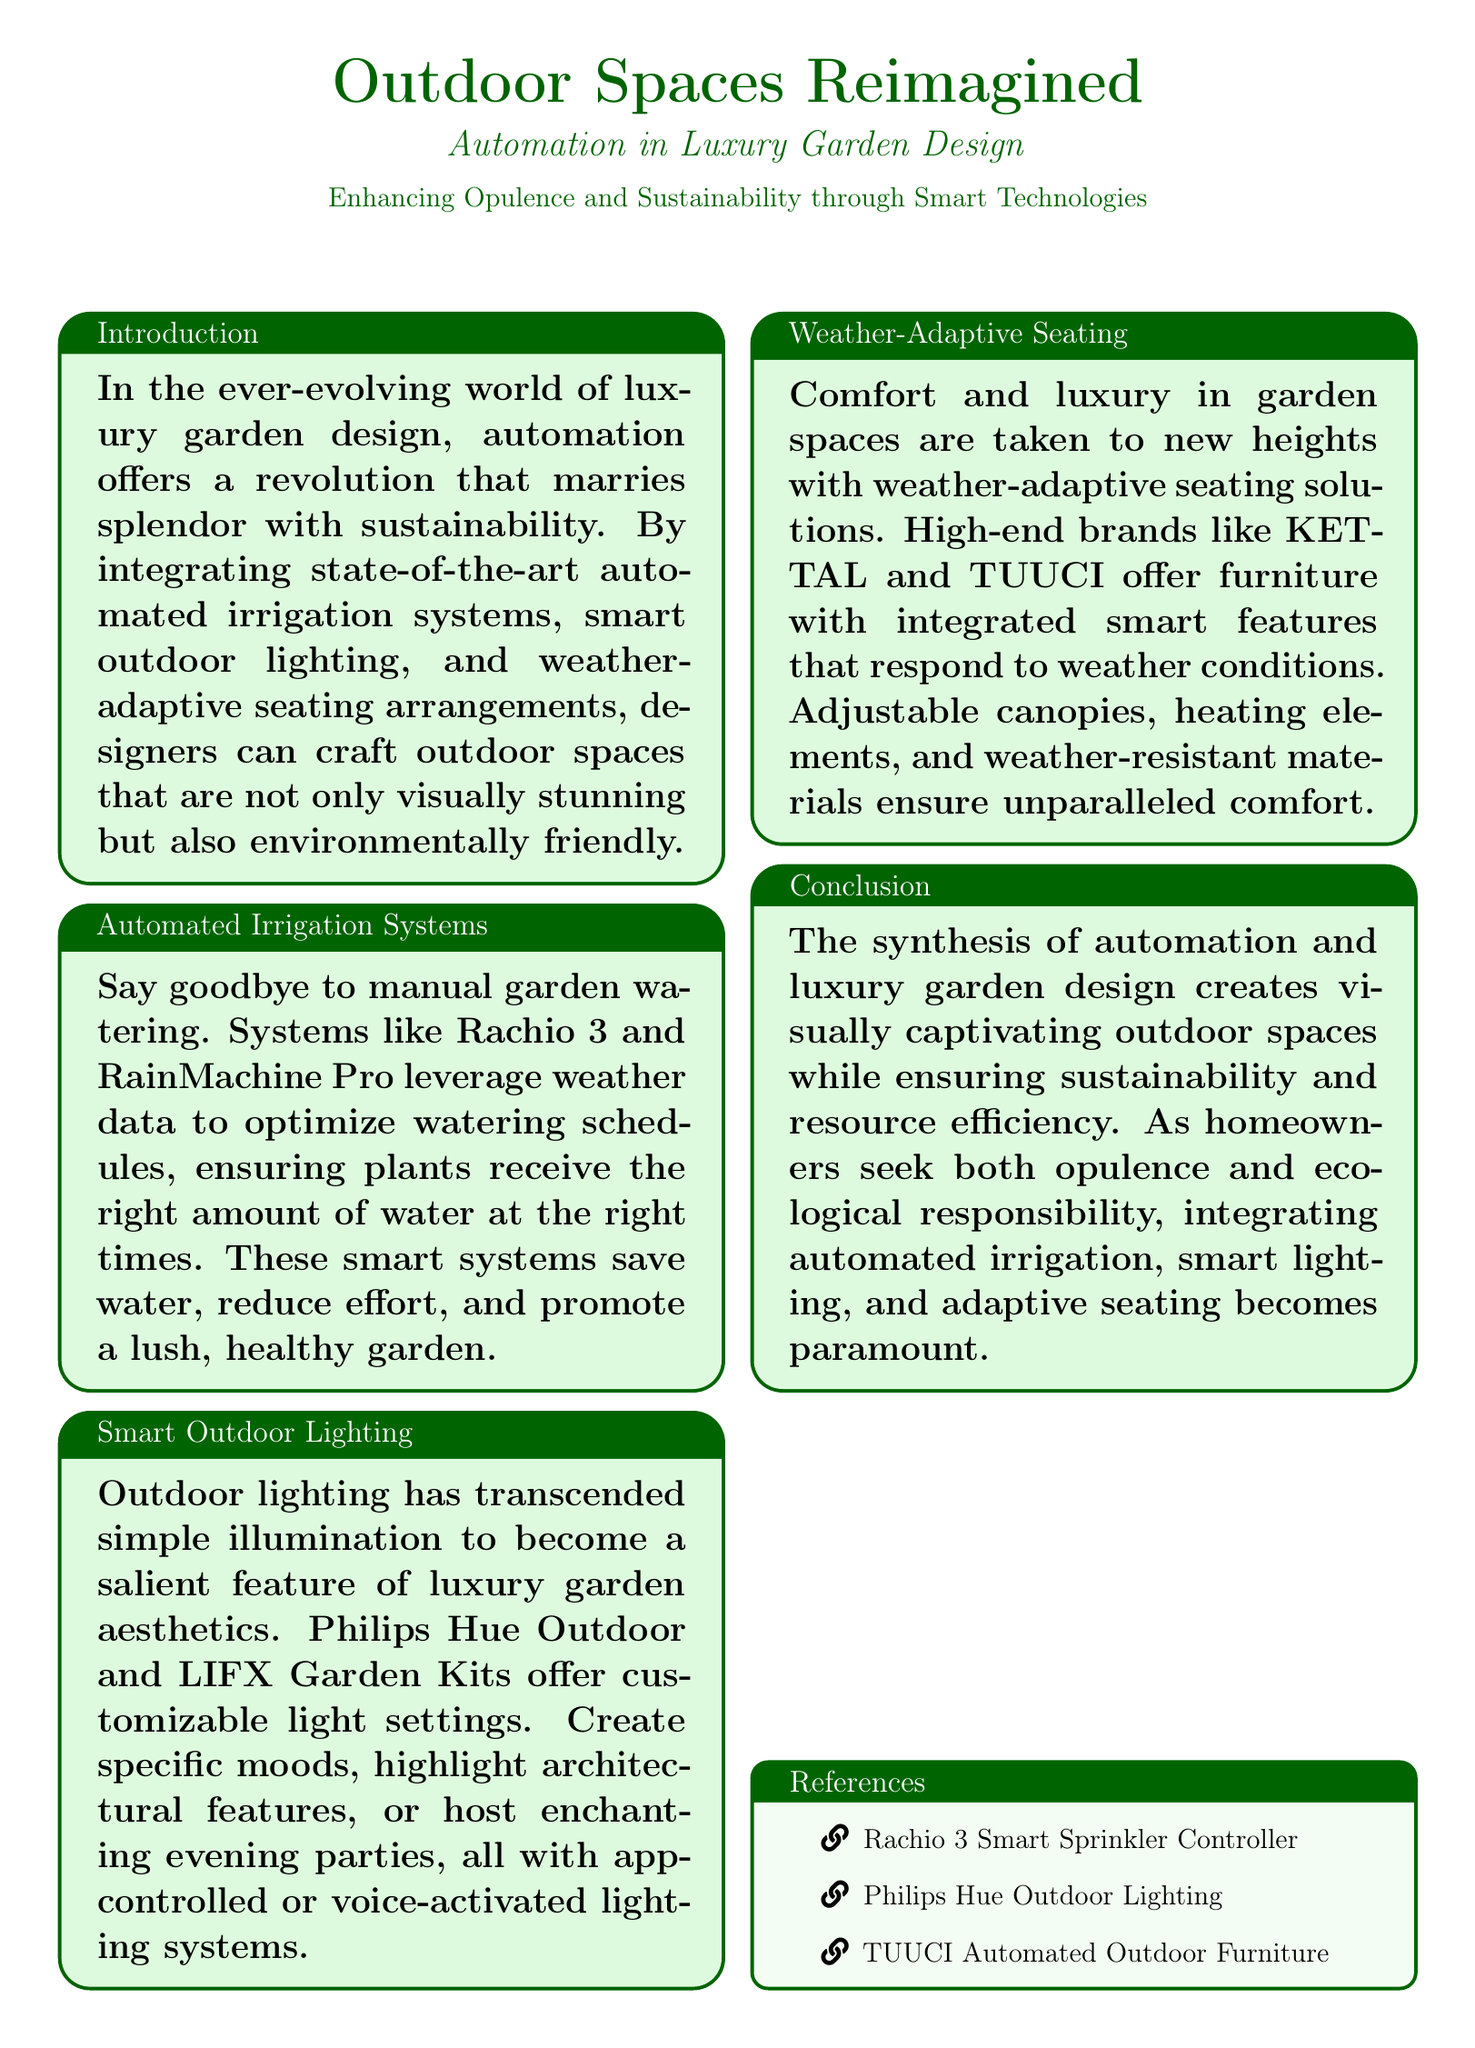what is the title of the document? The title of the document is presented prominently in the header section, highlighting the focus on outdoor spaces and automation.
Answer: Outdoor Spaces Reimagined who are the high-end brands mentioned for weather-adaptive seating? The section discussing weather-adaptive seating lists notable brands known for their integrated smart features.
Answer: KETTAL and TUUCI what systems are mentioned for automated irrigation? The document specifies brands that offer automated irrigation solutions to optimize garden watering.
Answer: Rachio 3 and RainMachine Pro what technology is used to control outdoor lighting? The document describes the functionality of outdoor lighting systems that can be adjusted remotely.
Answer: app-controlled or voice-activated how does automation impact luxury garden design? The introduction summarizes the benefits of integrating automation into luxury garden spaces, linking aesthetics with sustainability.
Answer: enhances opulence and sustainability what do automated irrigation systems help save? The document details the advantages of automated systems in terms of resource conservation.
Answer: water what are the customizable options provided by smart outdoor lighting? The section on smart outdoor lighting emphasizes the various ways to enhance garden aesthetics through lighting.
Answer: customizable light settings what features do weather-adaptive seating solutions include? The document lists the defining characteristics of advanced seating in outdoor spaces responding to environmental changes.
Answer: adjustable canopies, heating elements, weather-resistant materials 